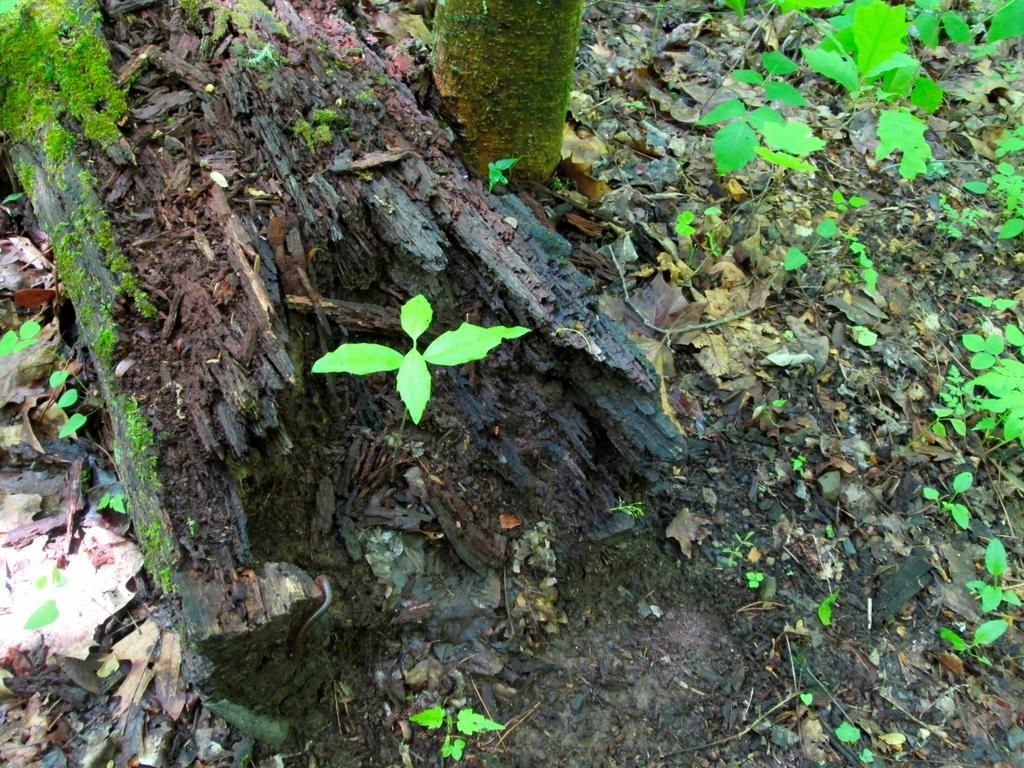Please provide a concise description of this image. In this image we can see a cut down tree, truncated tree, small plants and leaves are on the ground. 